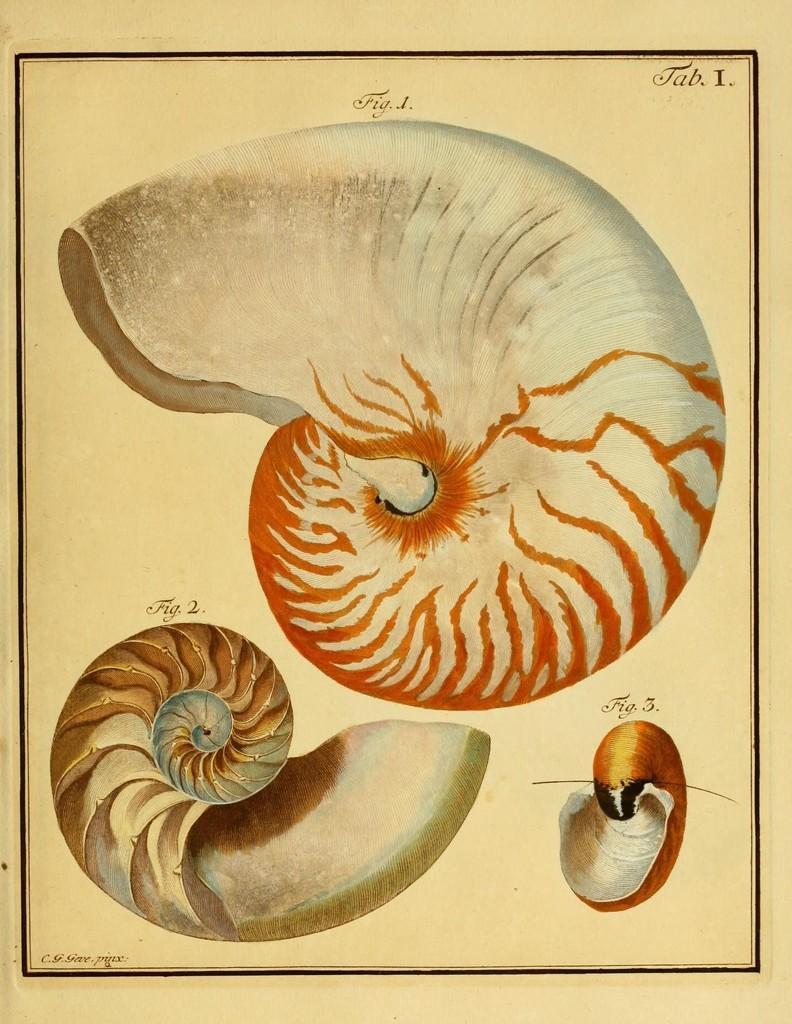Describe this image in one or two sentences. In this image we can see painting of some figures. 